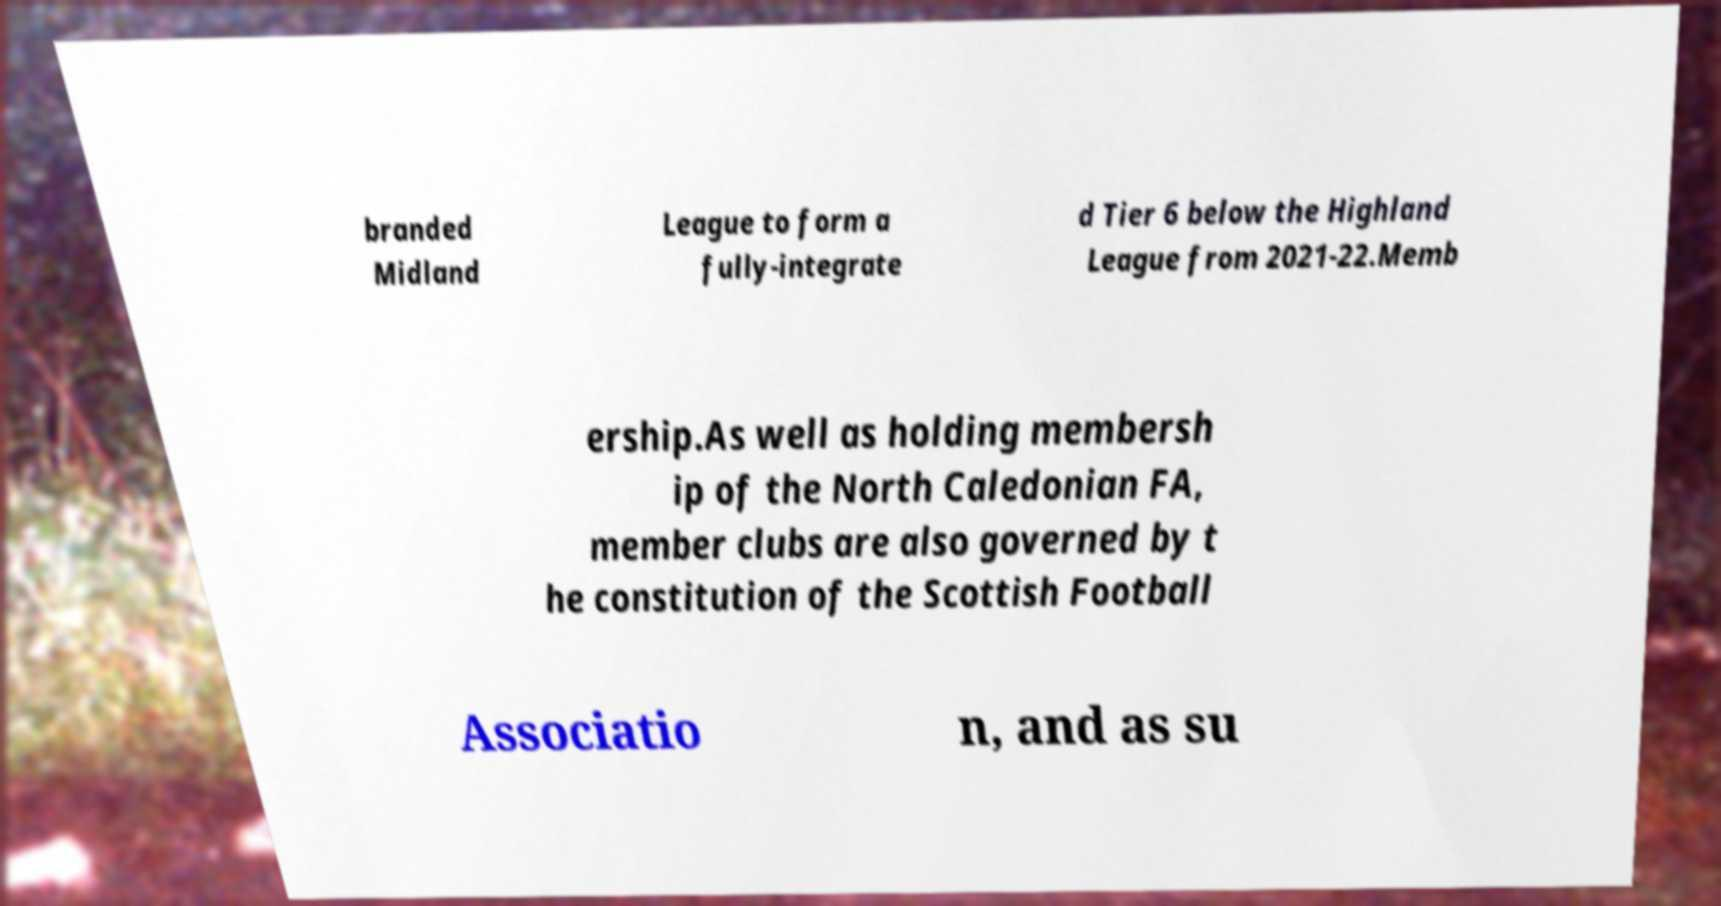Can you read and provide the text displayed in the image?This photo seems to have some interesting text. Can you extract and type it out for me? branded Midland League to form a fully-integrate d Tier 6 below the Highland League from 2021-22.Memb ership.As well as holding membersh ip of the North Caledonian FA, member clubs are also governed by t he constitution of the Scottish Football Associatio n, and as su 